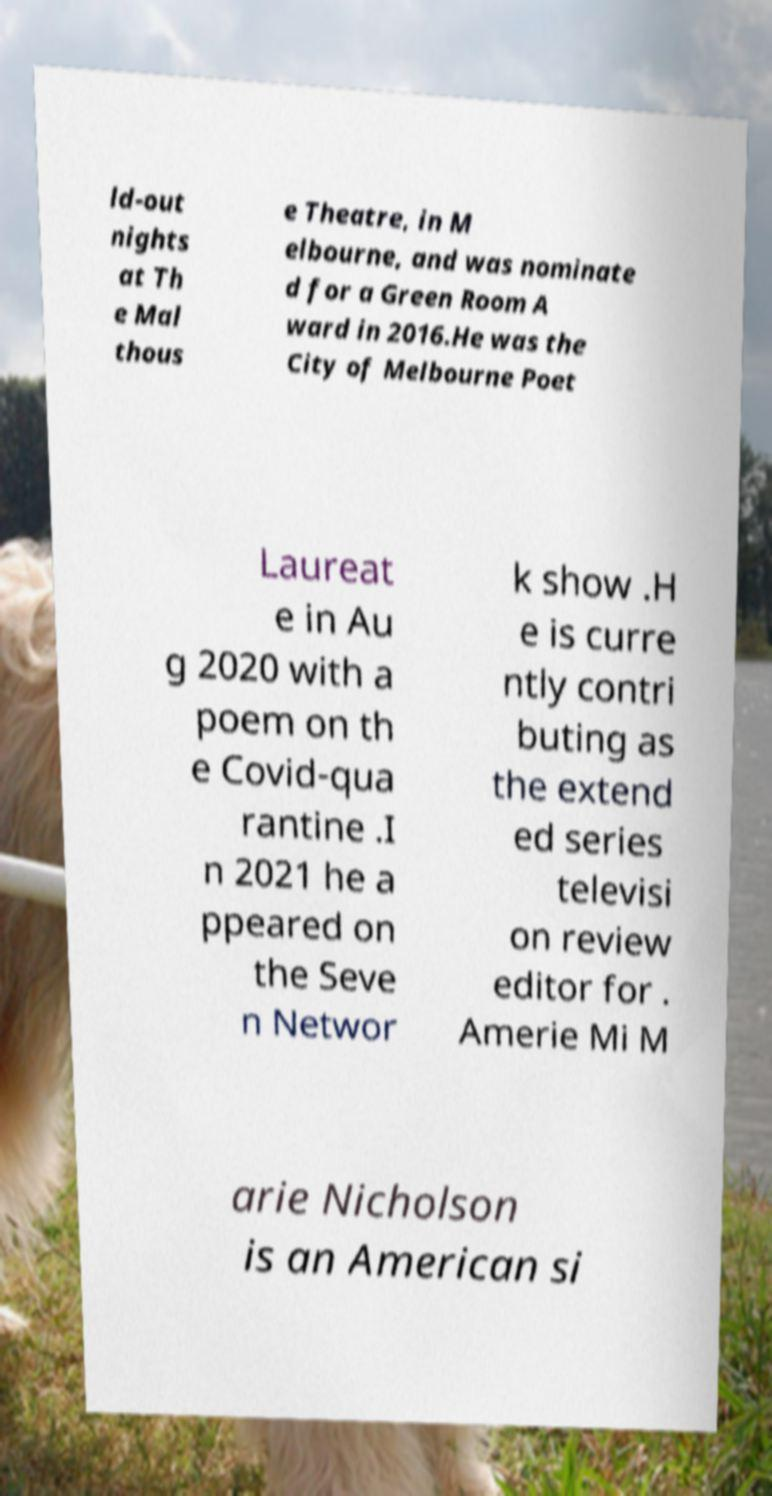For documentation purposes, I need the text within this image transcribed. Could you provide that? ld-out nights at Th e Mal thous e Theatre, in M elbourne, and was nominate d for a Green Room A ward in 2016.He was the City of Melbourne Poet Laureat e in Au g 2020 with a poem on th e Covid-qua rantine .I n 2021 he a ppeared on the Seve n Networ k show .H e is curre ntly contri buting as the extend ed series televisi on review editor for . Amerie Mi M arie Nicholson is an American si 